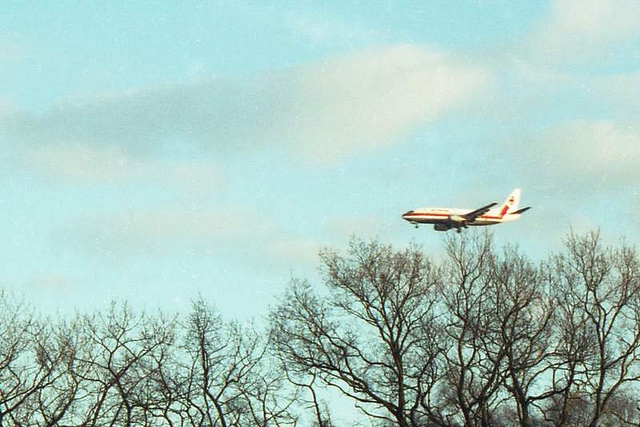Describe the objects in this image and their specific colors. I can see a airplane in lightblue, beige, black, gray, and khaki tones in this image. 